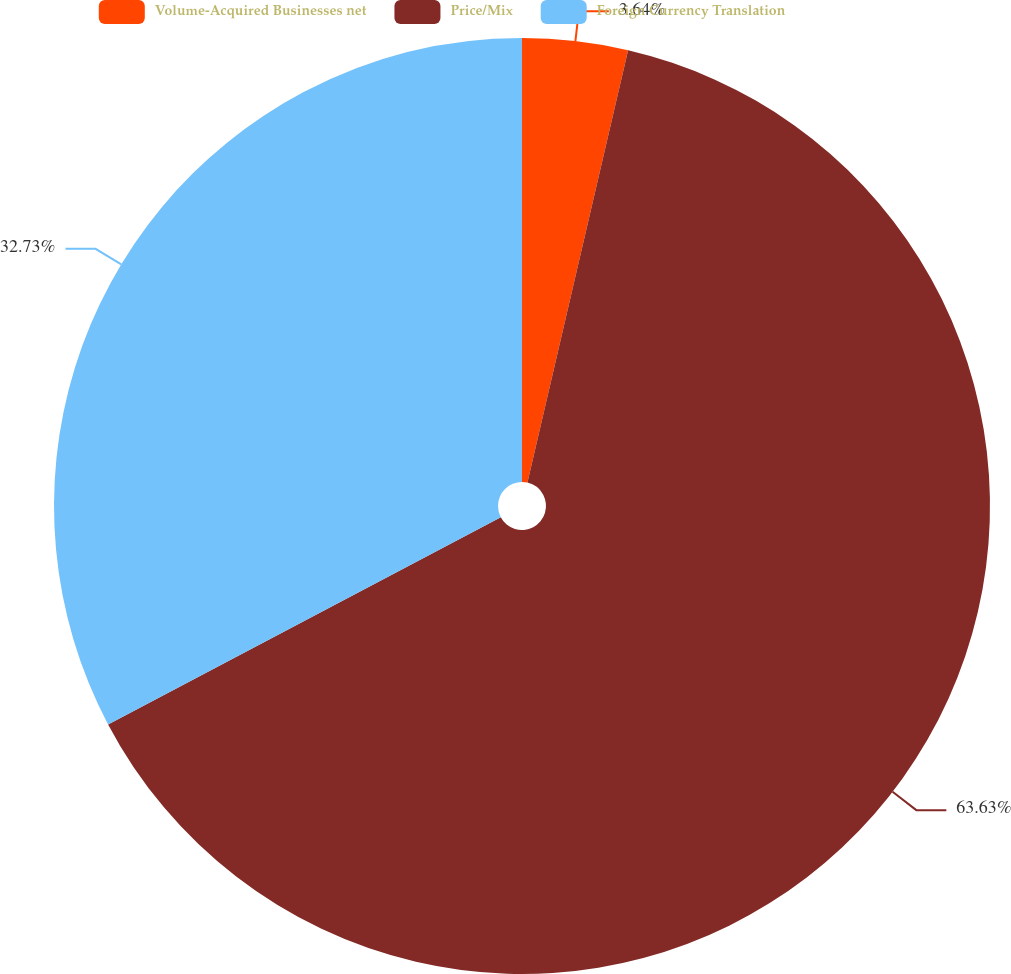Convert chart. <chart><loc_0><loc_0><loc_500><loc_500><pie_chart><fcel>Volume-Acquired Businesses net<fcel>Price/Mix<fcel>Foreign Currency Translation<nl><fcel>3.64%<fcel>63.64%<fcel>32.73%<nl></chart> 